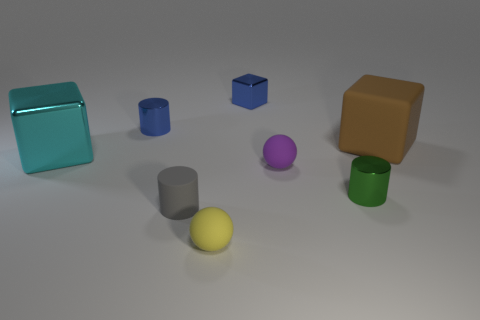Is the size of the metal block in front of the large matte cube the same as the metal block that is behind the big brown cube?
Offer a very short reply. No. What number of metal things are the same color as the small block?
Your answer should be compact. 1. What number of tiny objects are purple matte balls or brown metal things?
Provide a succinct answer. 1. Do the large cube to the right of the cyan metal block and the tiny gray thing have the same material?
Make the answer very short. Yes. There is a big thing that is right of the big cyan thing; what is its color?
Your answer should be very brief. Brown. Are there any yellow matte spheres of the same size as the rubber cylinder?
Ensure brevity in your answer.  Yes. What is the material of the purple object that is the same size as the blue cylinder?
Provide a short and direct response. Rubber. Does the brown matte thing have the same size as the cube that is on the left side of the small gray object?
Provide a succinct answer. Yes. There is a big cube that is to the left of the large brown rubber object; what is it made of?
Your answer should be very brief. Metal. Is the number of tiny metal objects right of the tiny yellow matte object the same as the number of blue things?
Ensure brevity in your answer.  Yes. 